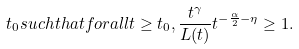<formula> <loc_0><loc_0><loc_500><loc_500>t _ { 0 } s u c h t h a t f o r a l l t \geq t _ { 0 } , \frac { t ^ { \gamma } } { L ( t ) } t ^ { - \frac { \alpha } { 2 } - \eta } \geq 1 .</formula> 